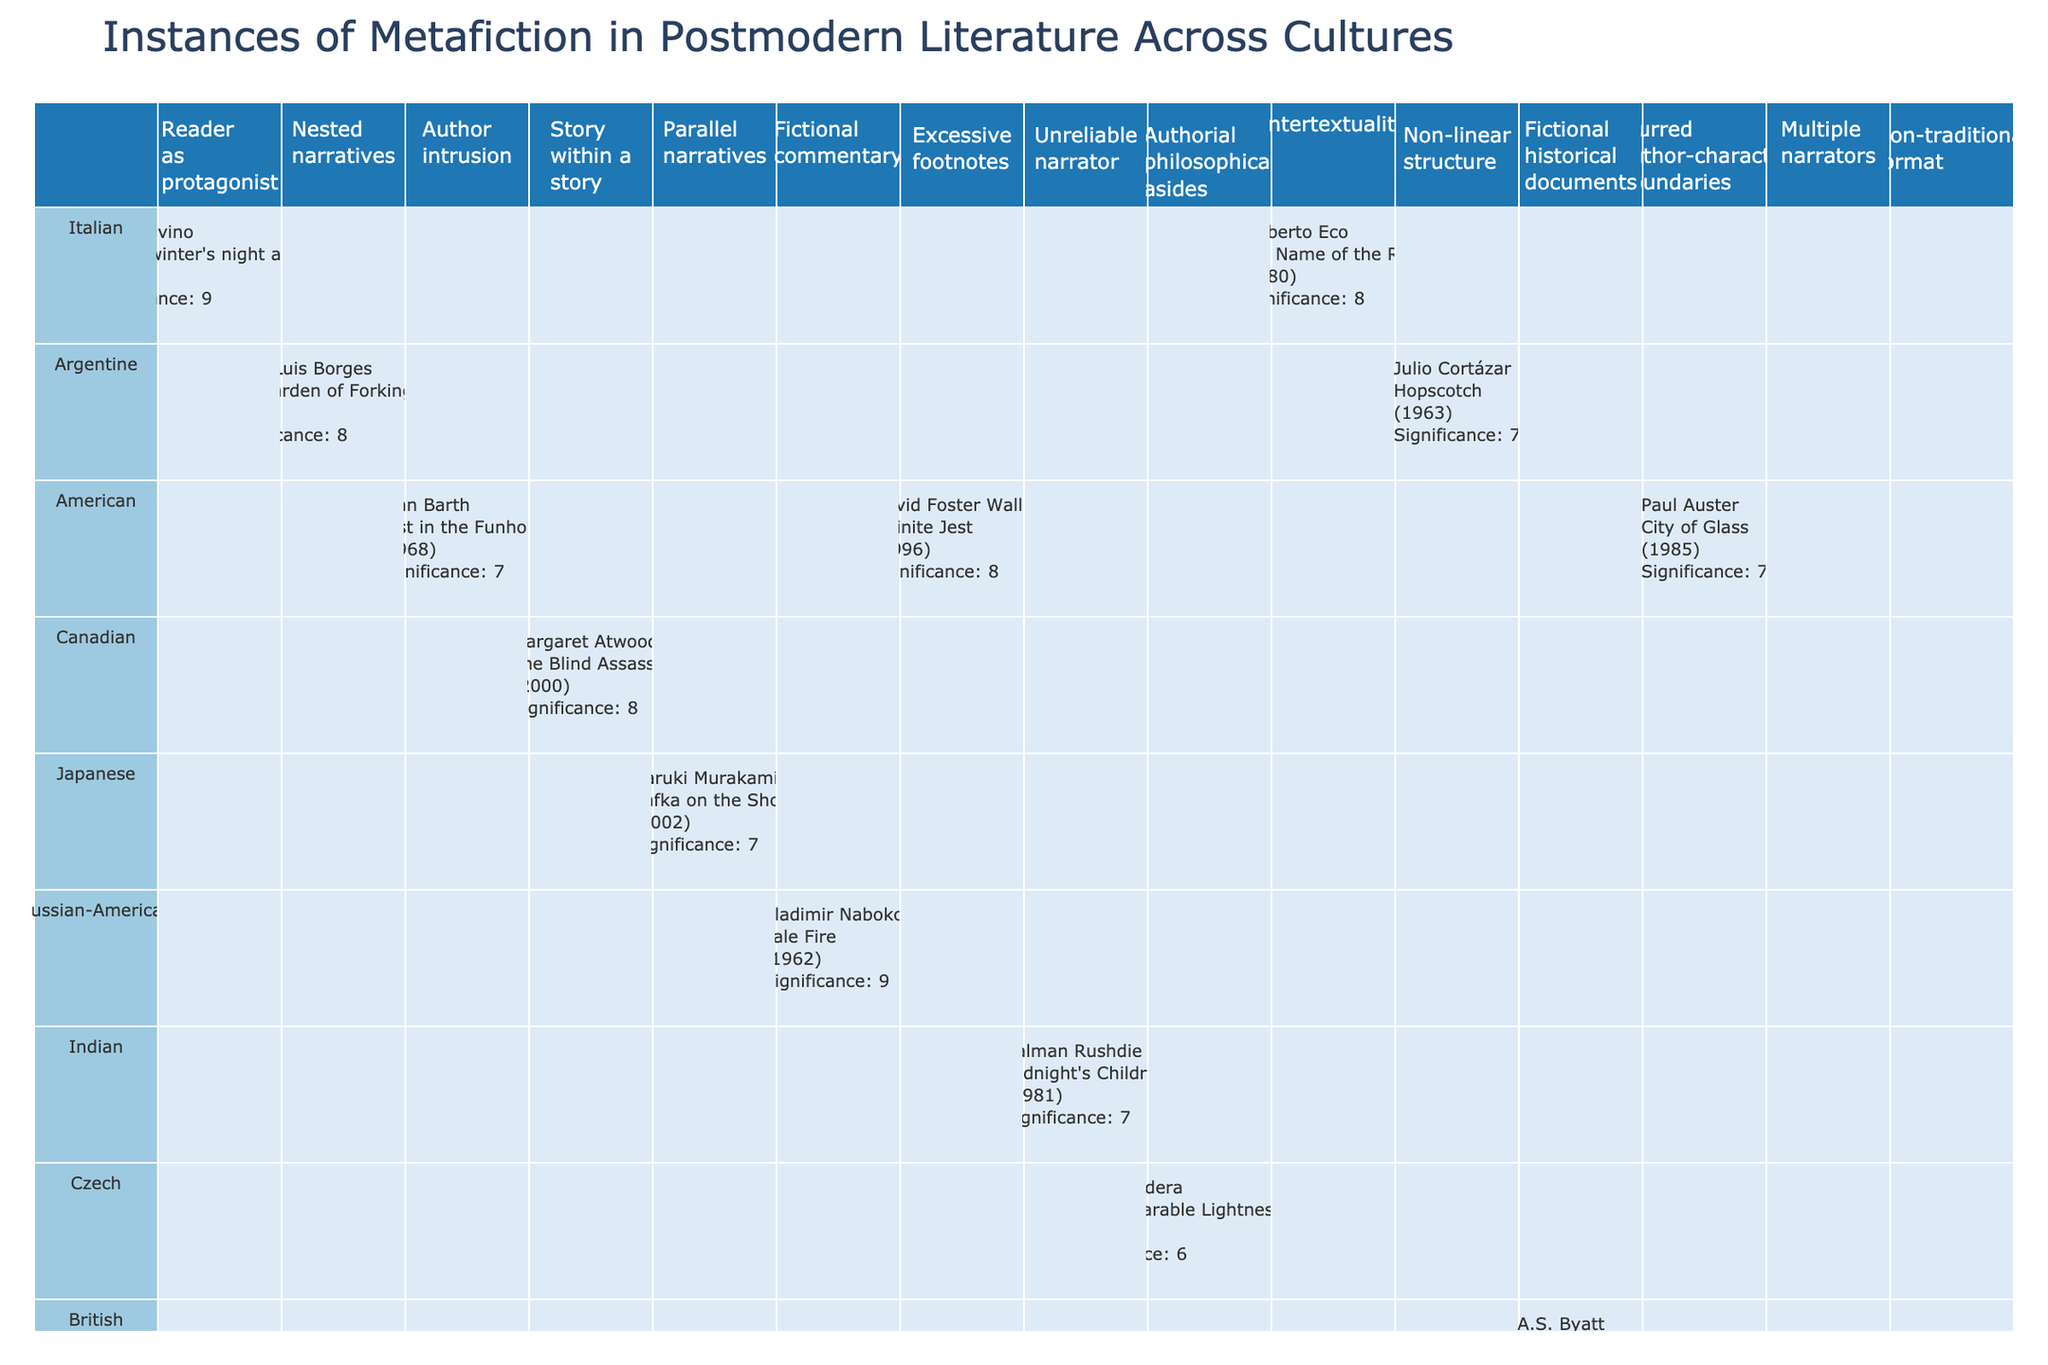What is the highest significance rating given to a metafictional element in the table? The table shows various significance ratings ranging from 6 to 9. Scanning the data, 'Reader as protagonist' in Calvino's work has a rating of 9, which is the highest.
Answer: 9 Which culture has the most instances of metafiction in the table? By checking the rows associated with each culture, we find that both Italian and Argentine cultures have 3 instances each (Calvino, Eco, and Nabokov for Italian; Borges, Cortázar, and Rushdie for Argentine). Therefore, they are tied for the most instances.
Answer: Italian and Argentine Is 'Story within a story' a metafictional element used in works from more than one culture? The table shows that 'Story within a story' is used only in Margaret Atwood's work from Canada, meaning it is not present in works from multiple cultures.
Answer: No Which author has the lowest significance rating for their metafictional element? By reviewing the significance ratings, Milan Kundera's 'Authorial philosophical asides' from 'The Unbearable Lightness of Being' has a 6, which is the lowest rating in the table.
Answer: Milan Kundera What is the average significance rating for Argentine metafictional works? The Argentine works listed are by Borges, who has a rating of 8, and Cortázar, who has a rating of 7. The average is calculated as (8 + 7) / 2 = 7.5.
Answer: 7.5 Is there a work that features both 'Non-linear structure' and a significance rating of 7 or higher in the table? The only work listed with 'Non-linear structure' is Cortázar's 'Hopscotch', which has a significance rating of 7, thus satisfying the criteria.
Answer: Yes Which metafictional element has the highest number of works associated with it across cultures? Reviewing the elements, 'Unreliable narrator' appears only once, and 'Story within a story' appears only once as well. Other elements do not show higher incidence. Therefore, there is no element with multiple works associated with it.
Answer: None What are the significance ratings for 'Nested narratives' and 'Parallel narratives'? Checking the table reveals that 'Nested narratives' in Borges' work has a significance rating of 8 and 'Parallel narratives' in Murakami's work has a significance rating of 7.
Answer: 8 and 7 How many authors from the table have a significance rating of 9? The works associated with a significance rating of 9 are Calvino's 'If on a winter's night a traveler' and Nabokov's 'Pale Fire', making a total of 2 authors.
Answer: 2 Are there any works with a significance rating of 6? Yes, A.S. Byatt's 'Possession' and Kundera's 'The Unbearable Lightness of Being' both carry a significance rating of 6 as noted in the table.
Answer: Yes 